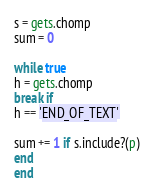Convert code to text. <code><loc_0><loc_0><loc_500><loc_500><_Ruby_>s = gets.chomp
sum = 0

while true
h = gets.chomp 
break if
h == 'END_OF_TEXT'

sum += 1 if s.include?(p) 
end
end
</code> 